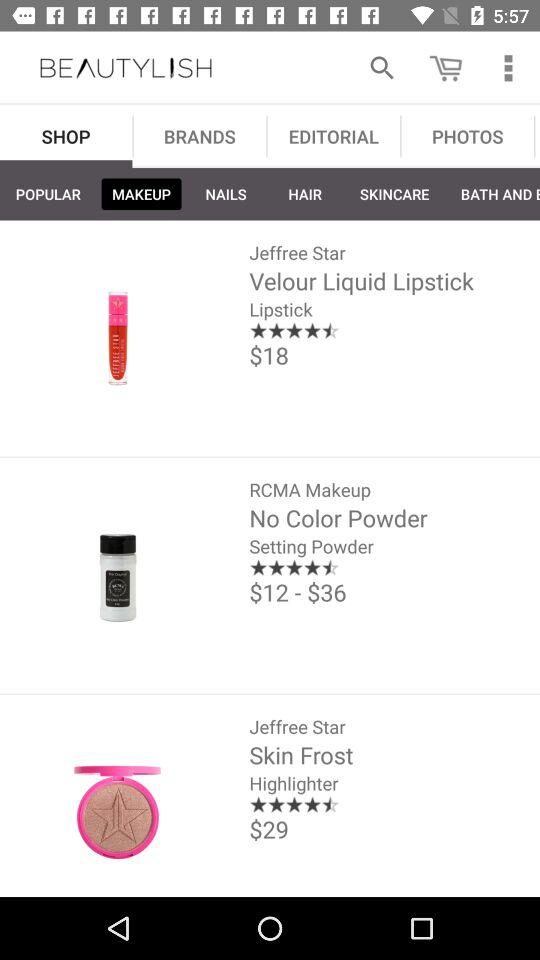How many reviews have there been on skin frost?
When the provided information is insufficient, respond with <no answer>. <no answer> 